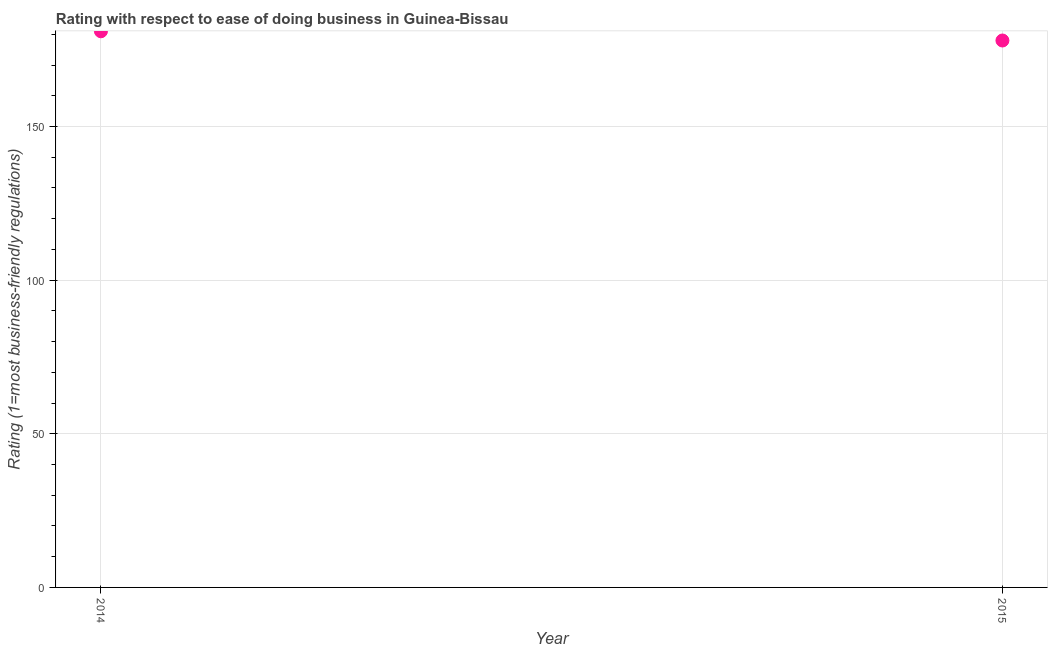What is the ease of doing business index in 2015?
Make the answer very short. 178. Across all years, what is the maximum ease of doing business index?
Offer a terse response. 181. Across all years, what is the minimum ease of doing business index?
Your answer should be very brief. 178. In which year was the ease of doing business index minimum?
Keep it short and to the point. 2015. What is the sum of the ease of doing business index?
Give a very brief answer. 359. What is the difference between the ease of doing business index in 2014 and 2015?
Provide a succinct answer. 3. What is the average ease of doing business index per year?
Your answer should be very brief. 179.5. What is the median ease of doing business index?
Your answer should be compact. 179.5. In how many years, is the ease of doing business index greater than 80 ?
Give a very brief answer. 2. What is the ratio of the ease of doing business index in 2014 to that in 2015?
Ensure brevity in your answer.  1.02. What is the difference between two consecutive major ticks on the Y-axis?
Provide a succinct answer. 50. Are the values on the major ticks of Y-axis written in scientific E-notation?
Your response must be concise. No. What is the title of the graph?
Your answer should be very brief. Rating with respect to ease of doing business in Guinea-Bissau. What is the label or title of the X-axis?
Your answer should be very brief. Year. What is the label or title of the Y-axis?
Offer a terse response. Rating (1=most business-friendly regulations). What is the Rating (1=most business-friendly regulations) in 2014?
Provide a short and direct response. 181. What is the Rating (1=most business-friendly regulations) in 2015?
Give a very brief answer. 178. 